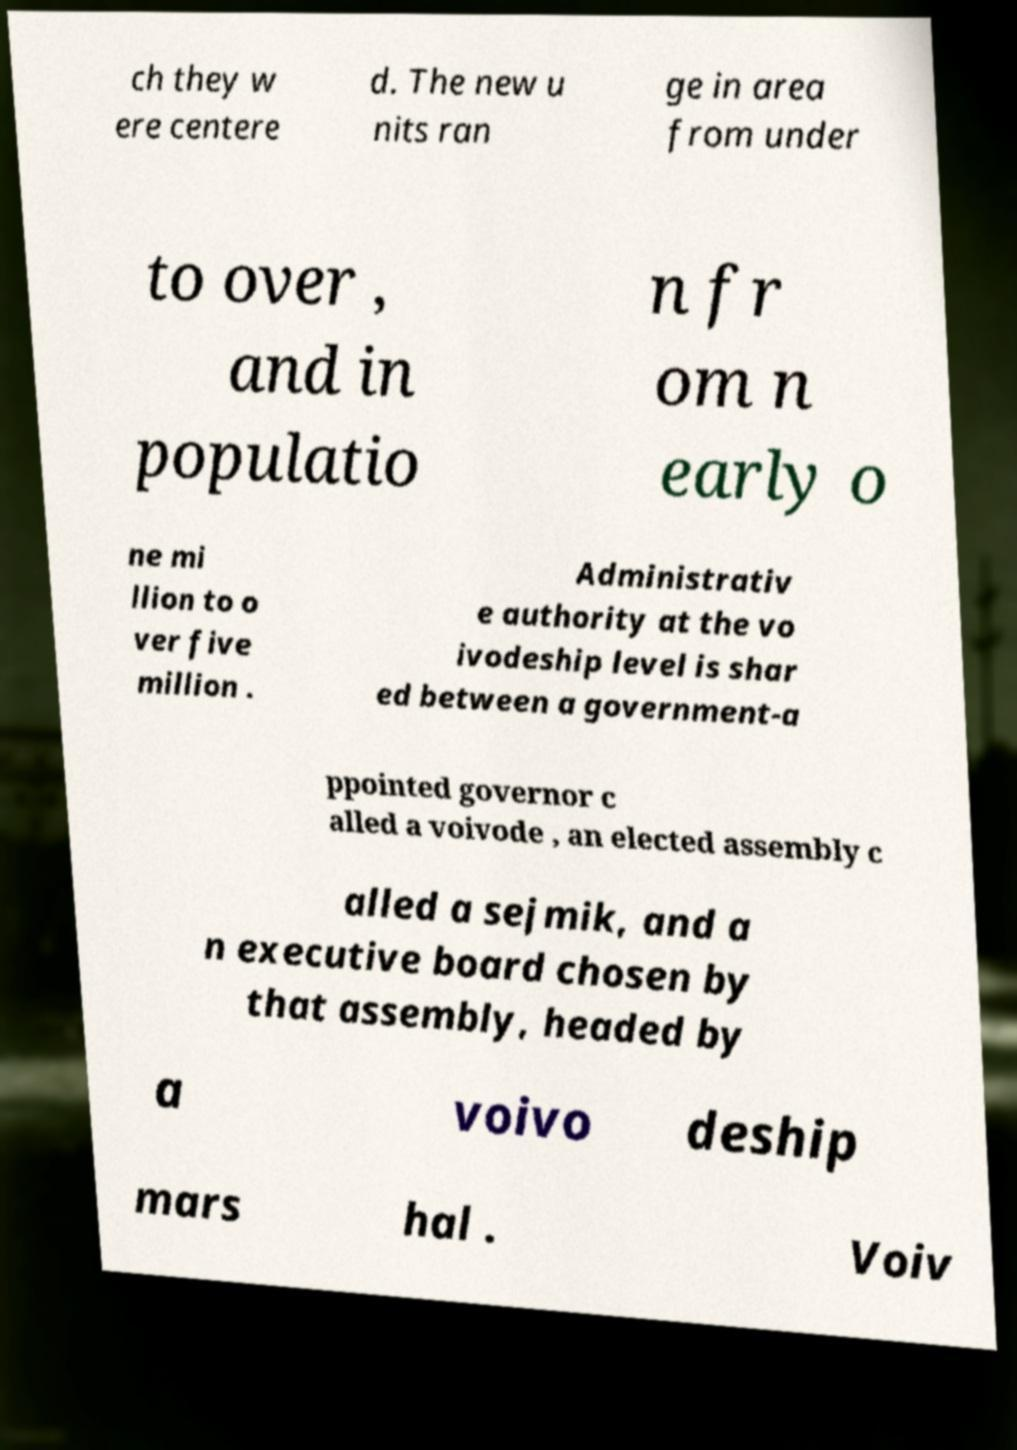Could you extract and type out the text from this image? ch they w ere centere d. The new u nits ran ge in area from under to over , and in populatio n fr om n early o ne mi llion to o ver five million . Administrativ e authority at the vo ivodeship level is shar ed between a government-a ppointed governor c alled a voivode , an elected assembly c alled a sejmik, and a n executive board chosen by that assembly, headed by a voivo deship mars hal . Voiv 